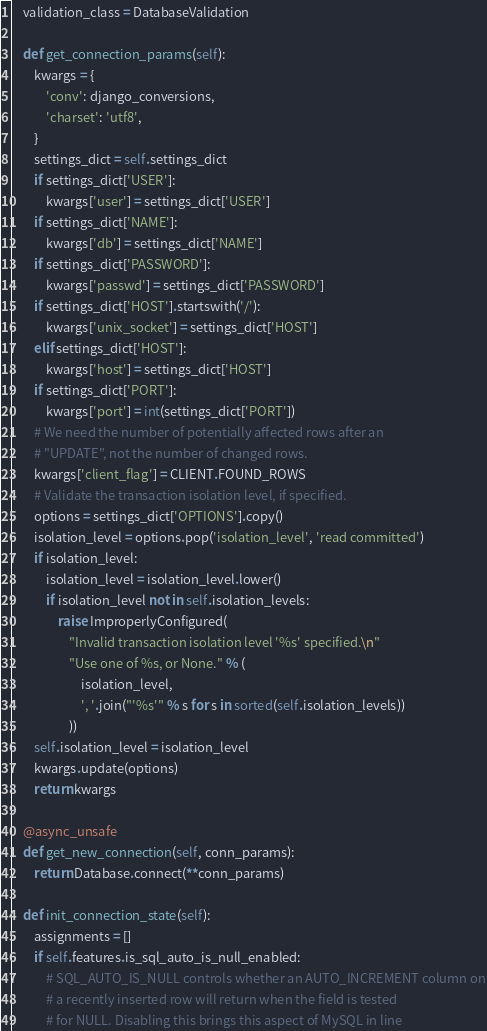<code> <loc_0><loc_0><loc_500><loc_500><_Python_>    validation_class = DatabaseValidation

    def get_connection_params(self):
        kwargs = {
            'conv': django_conversions,
            'charset': 'utf8',
        }
        settings_dict = self.settings_dict
        if settings_dict['USER']:
            kwargs['user'] = settings_dict['USER']
        if settings_dict['NAME']:
            kwargs['db'] = settings_dict['NAME']
        if settings_dict['PASSWORD']:
            kwargs['passwd'] = settings_dict['PASSWORD']
        if settings_dict['HOST'].startswith('/'):
            kwargs['unix_socket'] = settings_dict['HOST']
        elif settings_dict['HOST']:
            kwargs['host'] = settings_dict['HOST']
        if settings_dict['PORT']:
            kwargs['port'] = int(settings_dict['PORT'])
        # We need the number of potentially affected rows after an
        # "UPDATE", not the number of changed rows.
        kwargs['client_flag'] = CLIENT.FOUND_ROWS
        # Validate the transaction isolation level, if specified.
        options = settings_dict['OPTIONS'].copy()
        isolation_level = options.pop('isolation_level', 'read committed')
        if isolation_level:
            isolation_level = isolation_level.lower()
            if isolation_level not in self.isolation_levels:
                raise ImproperlyConfigured(
                    "Invalid transaction isolation level '%s' specified.\n"
                    "Use one of %s, or None." % (
                        isolation_level,
                        ', '.join("'%s'" % s for s in sorted(self.isolation_levels))
                    ))
        self.isolation_level = isolation_level
        kwargs.update(options)
        return kwargs

    @async_unsafe
    def get_new_connection(self, conn_params):
        return Database.connect(**conn_params)

    def init_connection_state(self):
        assignments = []
        if self.features.is_sql_auto_is_null_enabled:
            # SQL_AUTO_IS_NULL controls whether an AUTO_INCREMENT column on
            # a recently inserted row will return when the field is tested
            # for NULL. Disabling this brings this aspect of MySQL in line</code> 